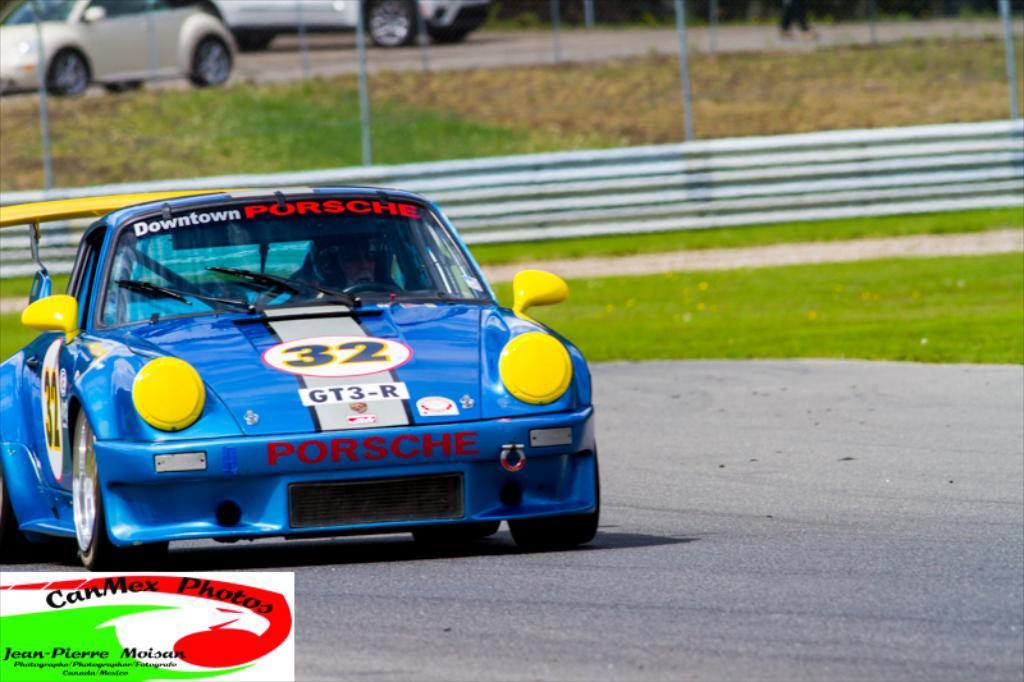Please provide a concise description of this image. In this image we can see a person is riding car on the road. In the background we can see fence, grass on the ground, poles, vehicles on the road, person's legs and on the left side we can see a poster edited on the image. 